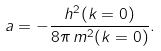Convert formula to latex. <formula><loc_0><loc_0><loc_500><loc_500>a = - \frac { h ^ { 2 } ( k = 0 ) } { 8 \pi \, m ^ { 2 } ( k = 0 ) } .</formula> 